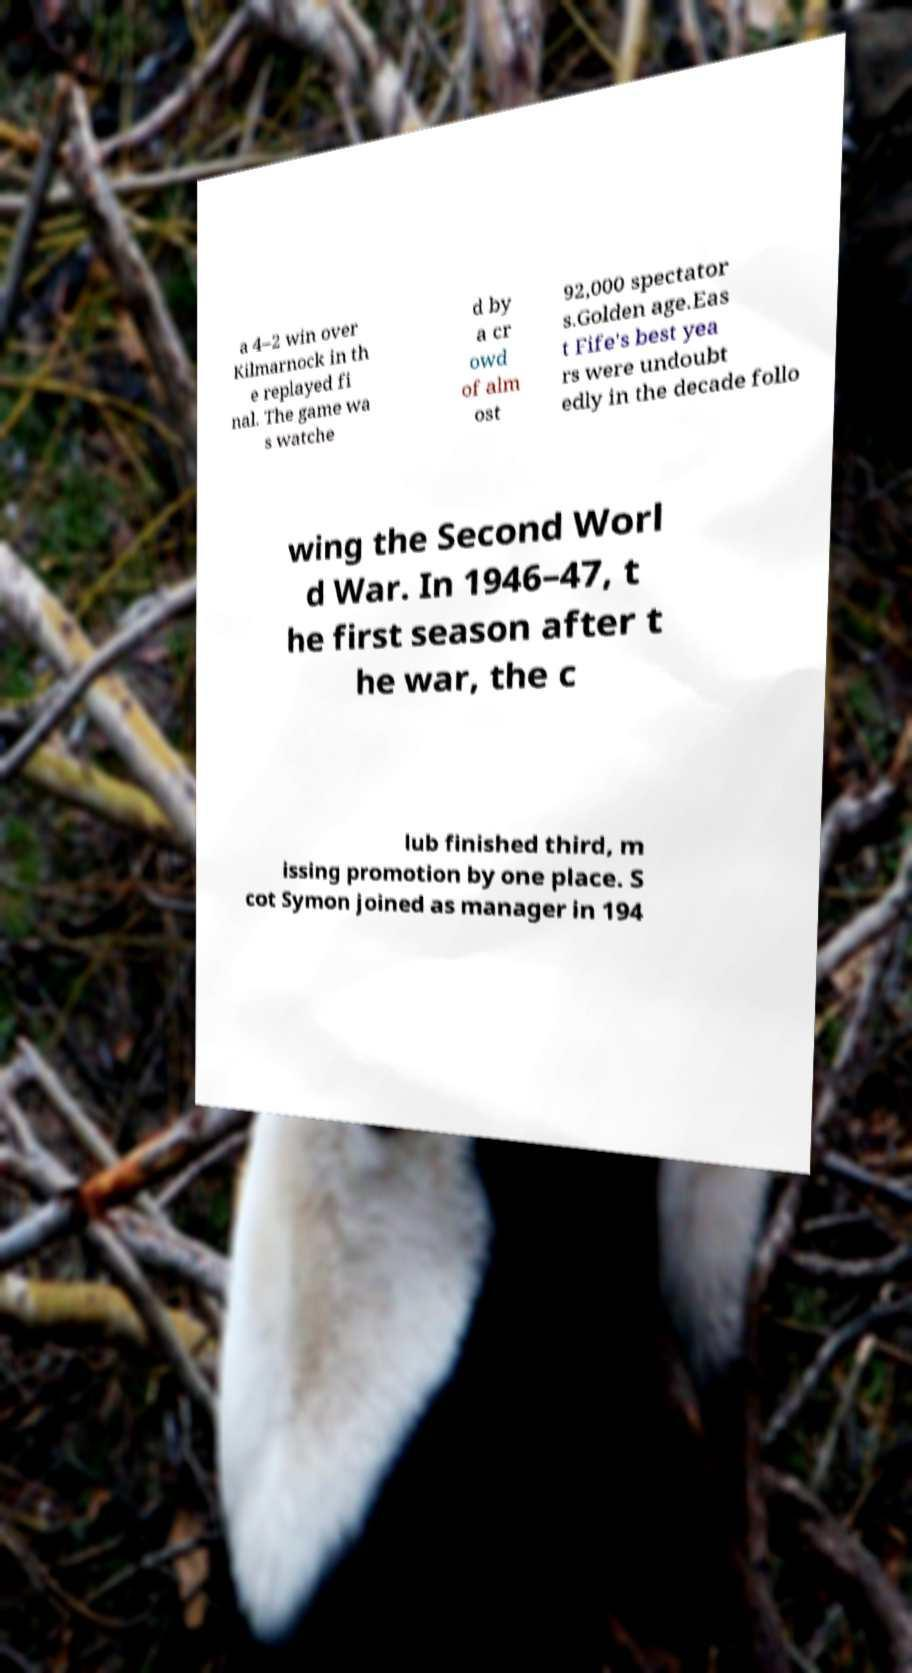Could you extract and type out the text from this image? a 4–2 win over Kilmarnock in th e replayed fi nal. The game wa s watche d by a cr owd of alm ost 92,000 spectator s.Golden age.Eas t Fife's best yea rs were undoubt edly in the decade follo wing the Second Worl d War. In 1946–47, t he first season after t he war, the c lub finished third, m issing promotion by one place. S cot Symon joined as manager in 194 